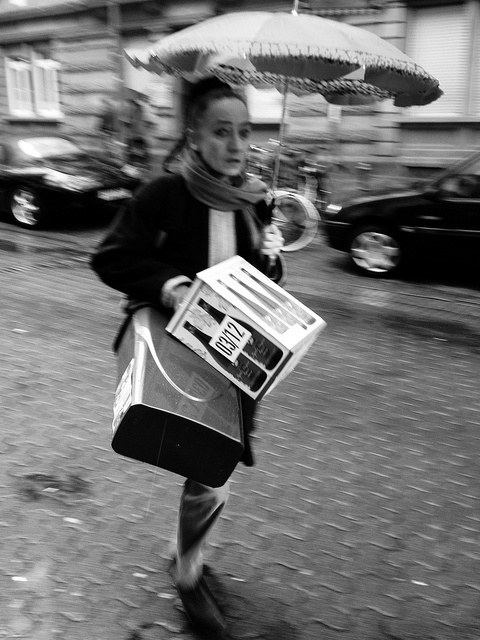Describe the objects in this image and their specific colors. I can see people in darkgray, black, gray, and lightgray tones, umbrella in darkgray, lightgray, gray, and black tones, suitcase in darkgray, black, gray, and lightgray tones, car in darkgray, black, gray, and lightgray tones, and car in darkgray, black, gray, and lightgray tones in this image. 